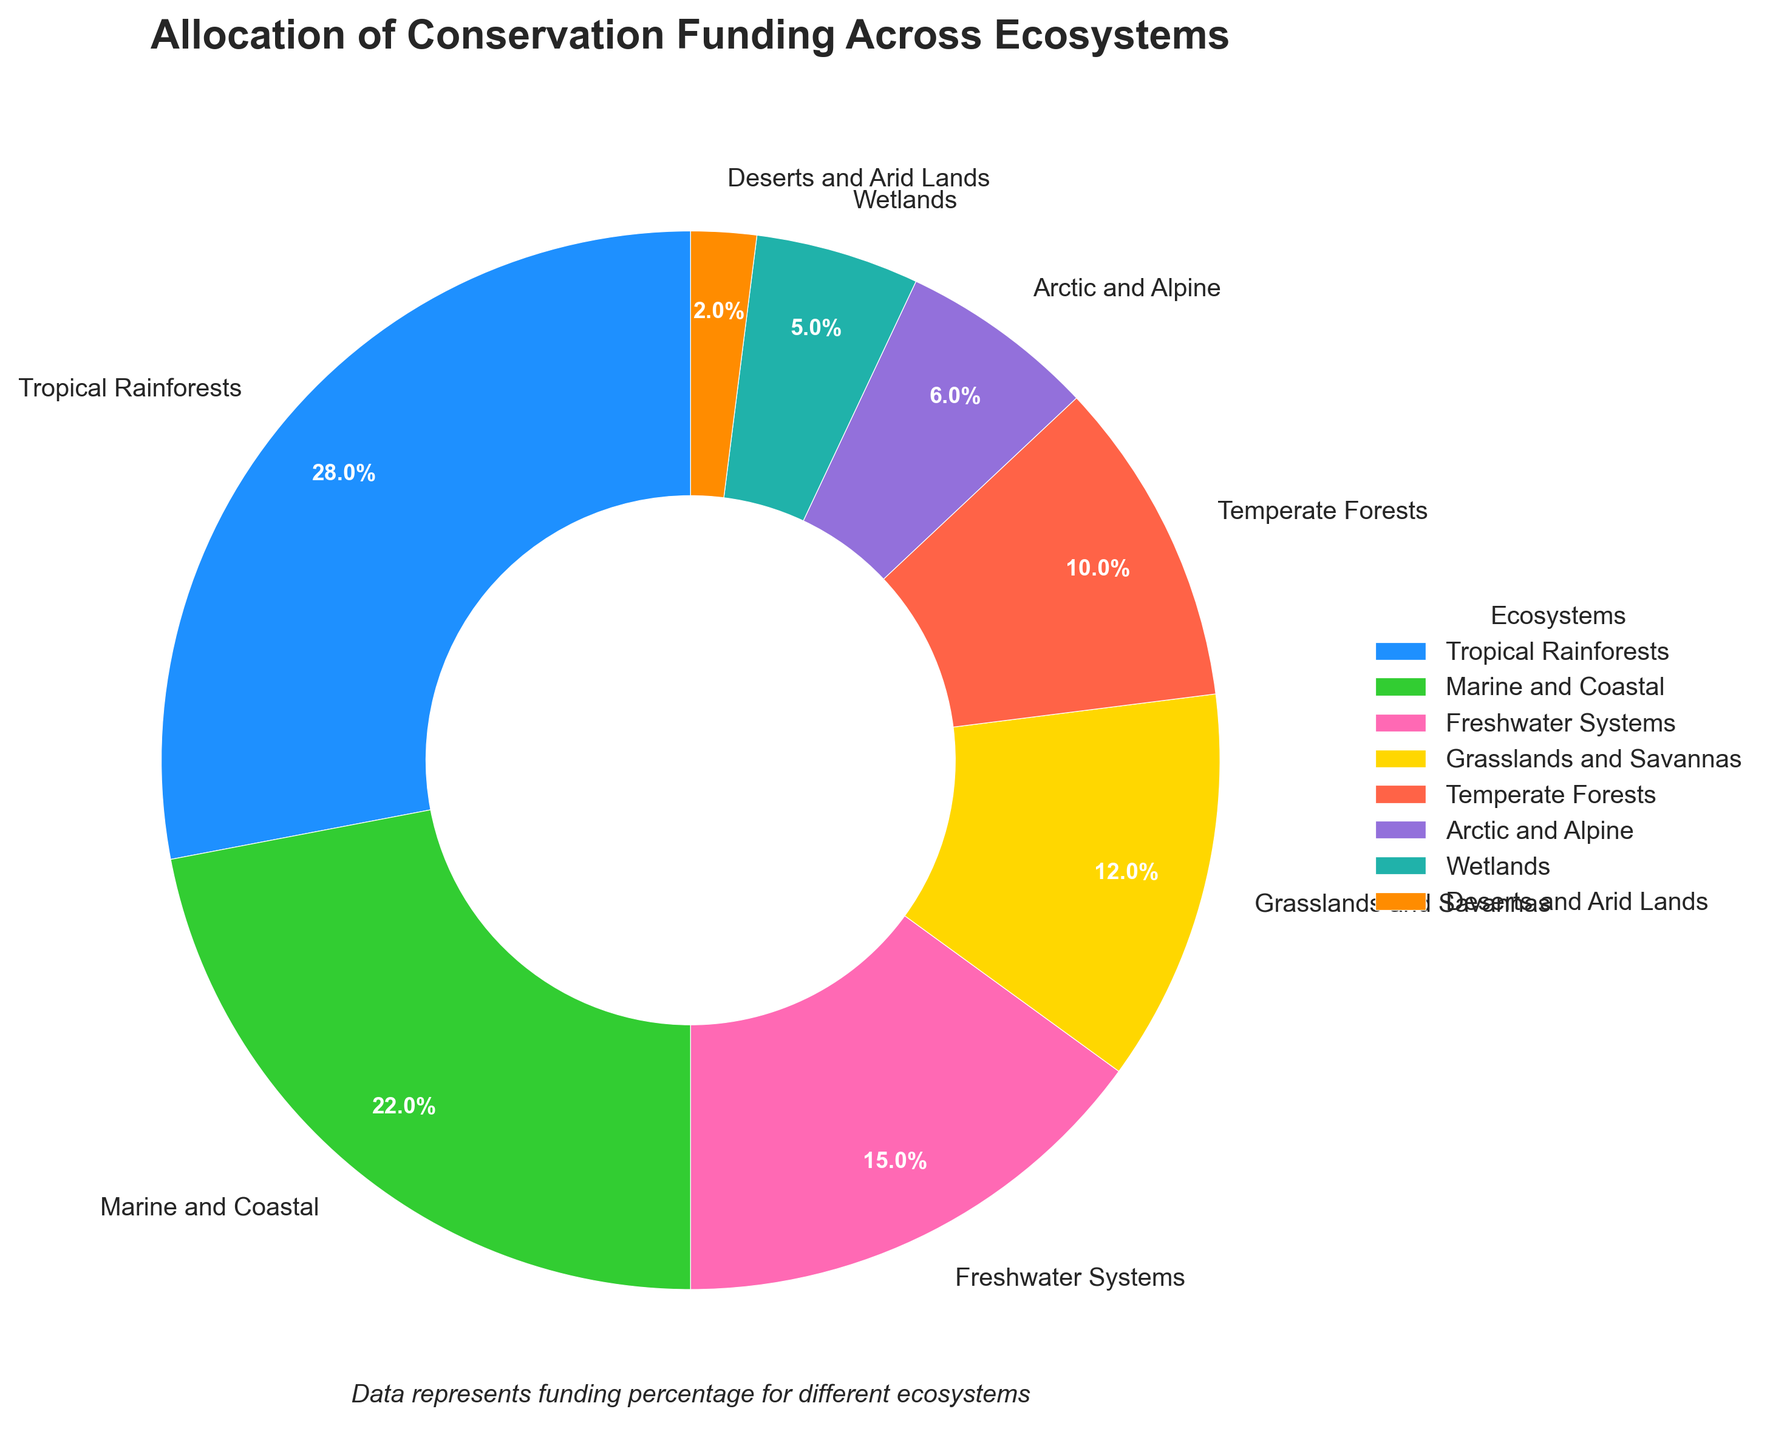Which ecosystem receives the highest percentage of conservation funding? The pie chart indicates the percentage of conservation funding allocated to each ecosystem. Tropical Rainforests have the largest slice of the pie chart, corresponding to 28%.
Answer: Tropical Rainforests What is the combined funding percentage for Marine and Coastal, and Freshwater Systems ecosystems? Referring to the pie chart, Marine and Coastal receives 22% and Freshwater Systems receive 15%. The combined percentage is 22% + 15% = 37%.
Answer: 37% How much more funding percentage do Tropical Rainforests receive compared to Deserts and Arid Lands? The pie chart shows that Tropical Rainforests receive 28% of the funding, while Deserts and Arid Lands receive 2%. The difference is 28% - 2% = 26%.
Answer: 26% Which ecosystems receive less than 10% of the total conservation funding? Referring to the pie chart, the ecosystems receiving less than 10% are Arctic and Alpine (6%), Wetlands (5%), and Deserts and Arid Lands (2%).
Answer: Arctic and Alpine, Wetlands, Deserts and Arid Lands What is the total percentage of funding allocated to Grasslands and Savannas, Temperate Forests, and Wetlands combined? The pie chart shows the percentages for Grasslands and Savannas (12%), Temperate Forests (10%), and Wetlands (5%). The total is 12% + 10% + 5% = 27%.
Answer: 27% Which ecosystem is depicted with the color green, and what percentage of funding does it receive? By visual inspection of the pie chart, the Marine and Coastal ecosystem is depicted with the color green. It receives 22% of the funding.
Answer: Marine and Coastal, 22% Is the funding percentage for Grasslands and Savannas greater, lesser, or equal to the funding percentage for Temperate Forests? The pie chart shows that Grasslands and Savannas receive 12% of the funding while Temperate Forests receive 10%. Thus, Grasslands and Savannas have a greater percentage.
Answer: Greater How many slices of the pie chart represent ecosystems that receive funding greater than 20%? By inspecting the pie chart, we see that Tropical Rainforests (28%) and Marine and Coastal (22%) are the only slices representing more than 20% each. There are 2 such slices.
Answer: 2 What percentage of conservation funding is allocated to ecosystems other than Tropical Rainforests? The pie chart shows Tropical Rainforests receive 28%. To find the percentage for other ecosystems, we subtract 28% from 100%, resulting in 100% - 28% = 72%.
Answer: 72% Among Arctic and Alpine, Wetlands, and Deserts and Arid Lands, which receives the least funding and what is the percentage? From the pie chart, Deserts and Arid Lands receive 2% funding, which is less than Arctic and Alpine (6%) and Wetlands (5%).
Answer: Deserts and Arid Lands, 2% 